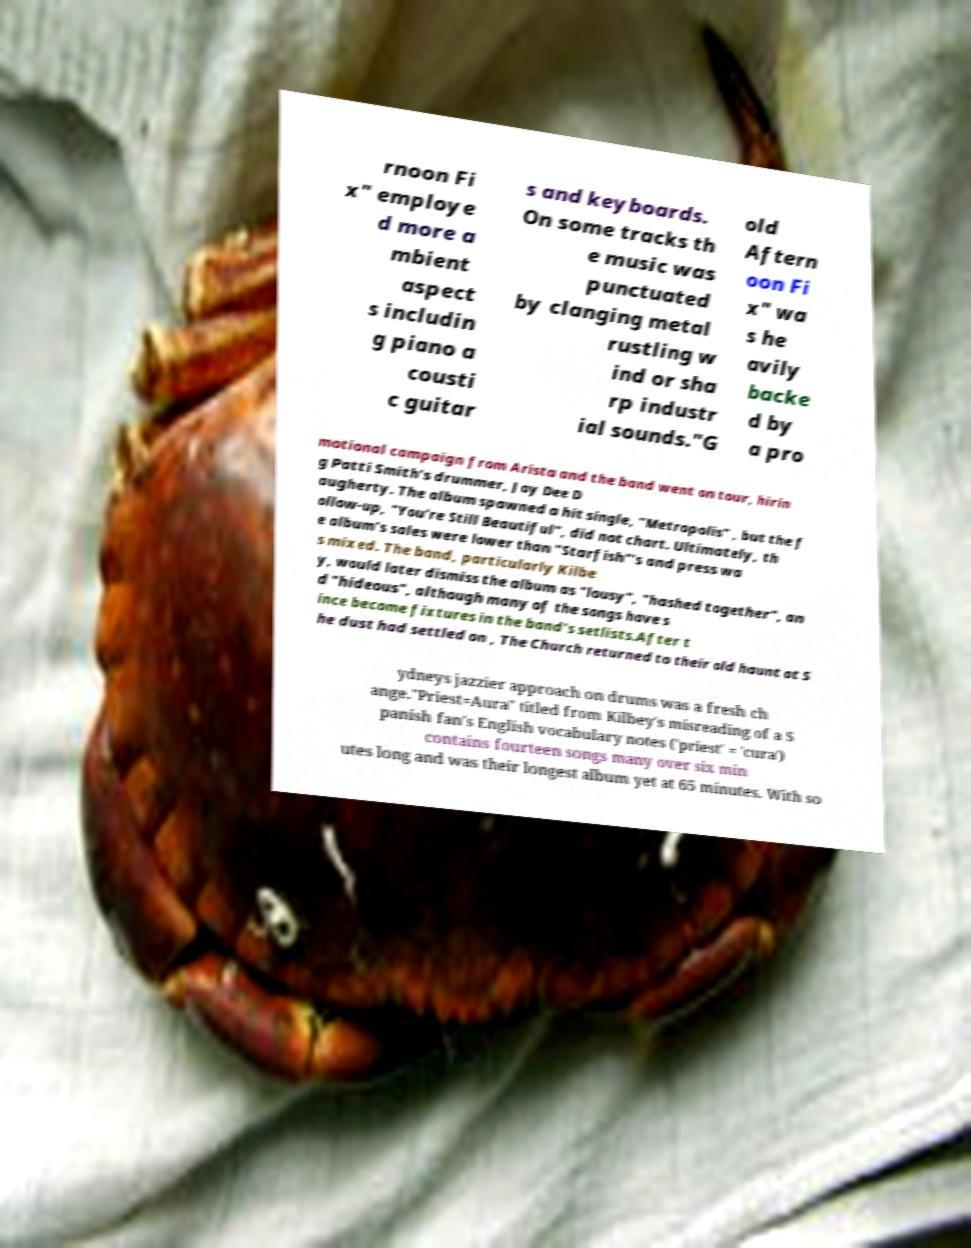Can you accurately transcribe the text from the provided image for me? rnoon Fi x" employe d more a mbient aspect s includin g piano a cousti c guitar s and keyboards. On some tracks th e music was punctuated by clanging metal rustling w ind or sha rp industr ial sounds."G old Aftern oon Fi x" wa s he avily backe d by a pro motional campaign from Arista and the band went on tour, hirin g Patti Smith's drummer, Jay Dee D augherty. The album spawned a hit single, "Metropolis" , but the f ollow-up, "You're Still Beautiful", did not chart. Ultimately, th e album's sales were lower than "Starfish"'s and press wa s mixed. The band, particularly Kilbe y, would later dismiss the album as "lousy", "hashed together", an d "hideous", although many of the songs have s ince become fixtures in the band's setlists.After t he dust had settled on , The Church returned to their old haunt at S ydneys jazzier approach on drums was a fresh ch ange."Priest=Aura" titled from Kilbey's misreading of a S panish fan's English vocabulary notes ('priest' = 'cura') contains fourteen songs many over six min utes long and was their longest album yet at 65 minutes. With so 